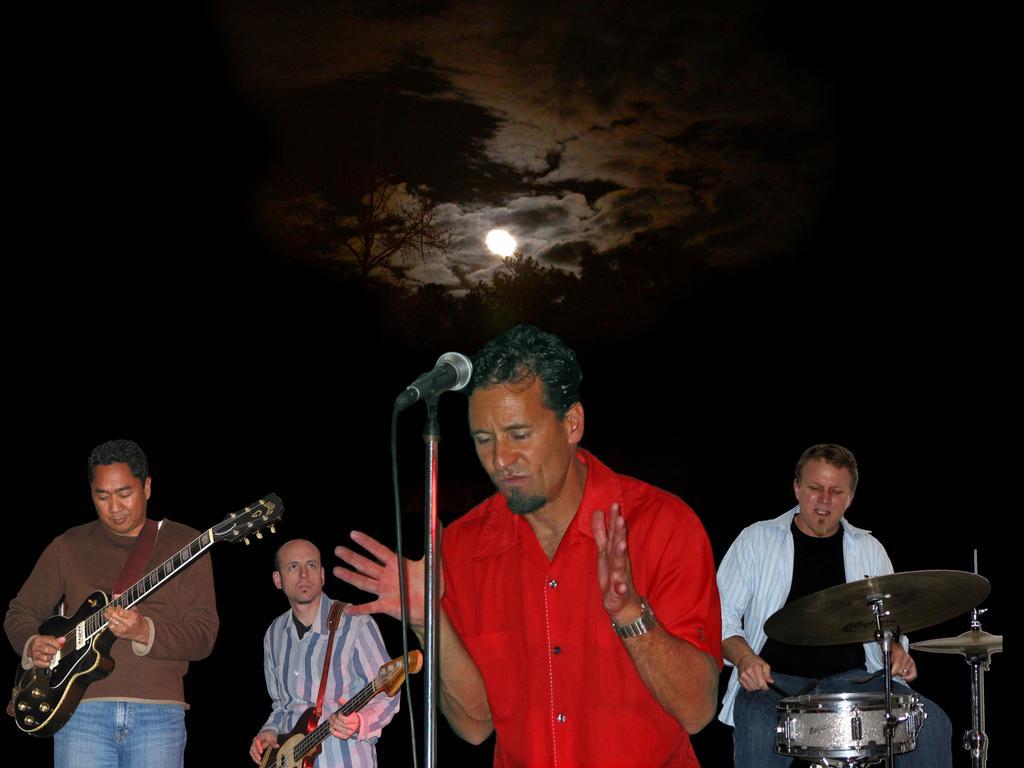Can you describe this image briefly? In this image we can see the sky which is dark in color and there is a moon at the center of the sky. There are four people, out of which three of them are playing musical instruments and there is a person who is standing at the center of the image, he is wearing red color shirt and he is looking down towards the mike which is present in-front of him and the person is wearing watch to his left hand. 